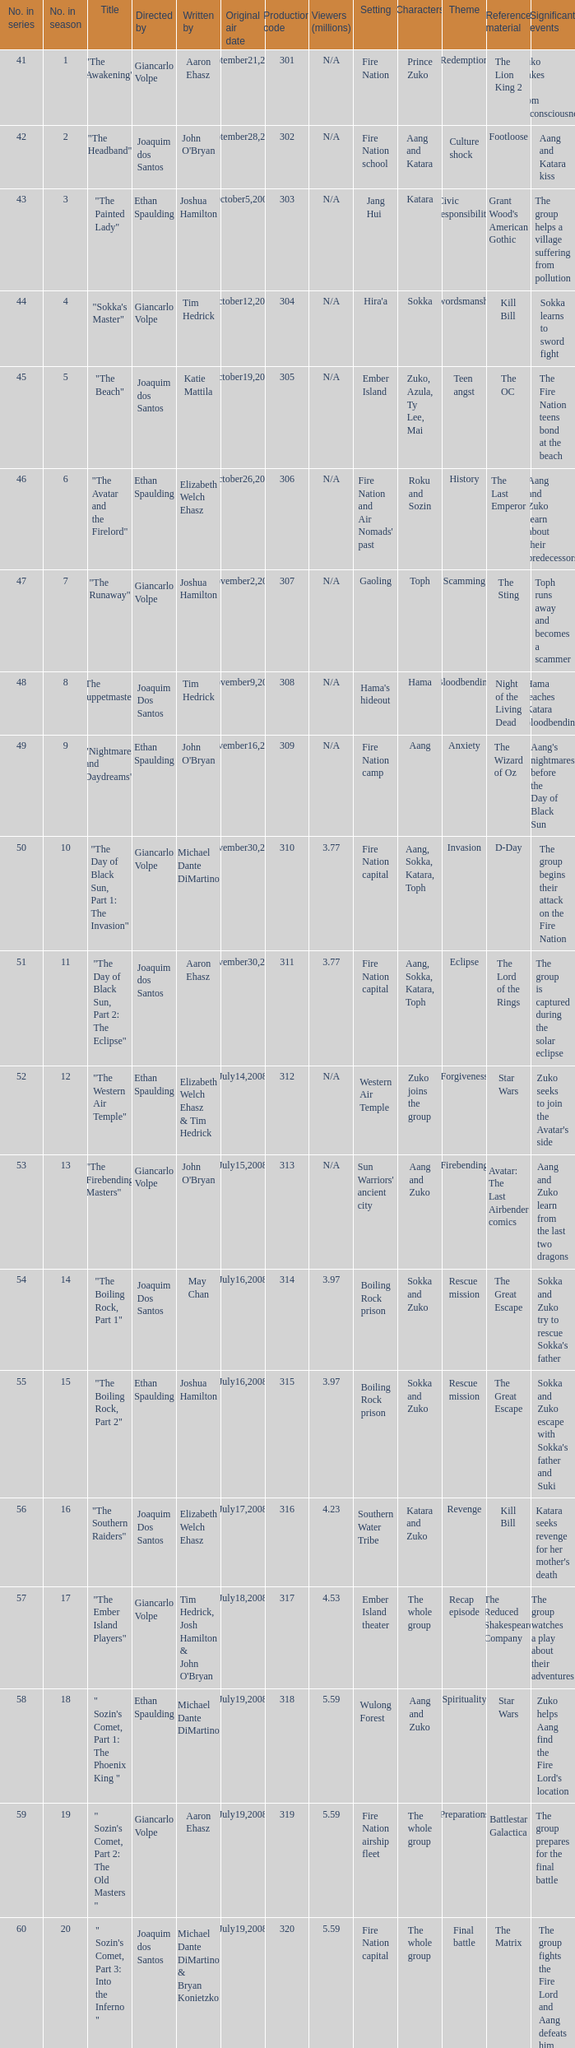Could you help me parse every detail presented in this table? {'header': ['No. in series', 'No. in season', 'Title', 'Directed by', 'Written by', 'Original air date', 'Production code', 'Viewers (millions)', 'Setting', 'Characters', 'Theme', 'Reference material', 'Significant events '], 'rows': [['41', '1', '"The Awakening"', 'Giancarlo Volpe', 'Aaron Ehasz', 'September21,2007', '301', 'N/A', 'Fire Nation', 'Prince Zuko', 'Redemption', 'The Lion King 2', 'Zuko wakes up from unconsciousness '], ['42', '2', '"The Headband"', 'Joaquim dos Santos', "John O'Bryan", 'September28,2007', '302', 'N/A', 'Fire Nation school', 'Aang and Katara', 'Culture shock', 'Footloose', 'Aang and Katara kiss '], ['43', '3', '"The Painted Lady"', 'Ethan Spaulding', 'Joshua Hamilton', 'October5,2007', '303', 'N/A', 'Jang Hui', 'Katara', 'Civic responsibility', "Grant Wood's American Gothic", 'The group helps a village suffering from pollution '], ['44', '4', '"Sokka\'s Master"', 'Giancarlo Volpe', 'Tim Hedrick', 'October12,2007', '304', 'N/A', "Hira'a", 'Sokka', 'Swordsmanship', 'Kill Bill', 'Sokka learns to sword fight '], ['45', '5', '"The Beach"', 'Joaquim dos Santos', 'Katie Mattila', 'October19,2007', '305', 'N/A', 'Ember Island', 'Zuko, Azula, Ty Lee, Mai', 'Teen angst', 'The OC', 'The Fire Nation teens bond at the beach '], ['46', '6', '"The Avatar and the Firelord"', 'Ethan Spaulding', 'Elizabeth Welch Ehasz', 'October26,2007', '306', 'N/A', "Fire Nation and Air Nomads' past", 'Roku and Sozin', 'History', 'The Last Emperor', 'Aang and Zuko learn about their predecessors '], ['47', '7', '"The Runaway"', 'Giancarlo Volpe', 'Joshua Hamilton', 'November2,2007', '307', 'N/A', 'Gaoling', 'Toph', 'Scamming', 'The Sting', 'Toph runs away and becomes a scammer '], ['48', '8', '"The Puppetmaster"', 'Joaquim Dos Santos', 'Tim Hedrick', 'November9,2007', '308', 'N/A', "Hama's hideout", 'Hama', 'Bloodbending', 'Night of the Living Dead', 'Hama teaches Katara bloodbending '], ['49', '9', '"Nightmares and Daydreams"', 'Ethan Spaulding', "John O'Bryan", 'November16,2007', '309', 'N/A', 'Fire Nation camp', 'Aang', 'Anxiety', 'The Wizard of Oz', "Aang's nightmares before the Day of Black Sun "], ['50', '10', '"The Day of Black Sun, Part 1: The Invasion"', 'Giancarlo Volpe', 'Michael Dante DiMartino', 'November30,2007', '310', '3.77', 'Fire Nation capital', 'Aang, Sokka, Katara, Toph', 'Invasion', 'D-Day', 'The group begins their attack on the Fire Nation '], ['51', '11', '"The Day of Black Sun, Part 2: The Eclipse"', 'Joaquim dos Santos', 'Aaron Ehasz', 'November30,2007', '311', '3.77', 'Fire Nation capital', 'Aang, Sokka, Katara, Toph', 'Eclipse', 'The Lord of the Rings', 'The group is captured during the solar eclipse '], ['52', '12', '"The Western Air Temple"', 'Ethan Spaulding', 'Elizabeth Welch Ehasz & Tim Hedrick', 'July14,2008', '312', 'N/A', 'Western Air Temple', 'Zuko joins the group', 'Forgiveness', 'Star Wars', "Zuko seeks to join the Avatar's side "], ['53', '13', '"The Firebending Masters"', 'Giancarlo Volpe', "John O'Bryan", 'July15,2008', '313', 'N/A', "Sun Warriors' ancient city", 'Aang and Zuko', 'Firebending', 'Avatar: The Last Airbender comics', 'Aang and Zuko learn from the last two dragons '], ['54', '14', '"The Boiling Rock, Part 1"', 'Joaquim Dos Santos', 'May Chan', 'July16,2008', '314', '3.97', 'Boiling Rock prison', 'Sokka and Zuko', 'Rescue mission', 'The Great Escape', "Sokka and Zuko try to rescue Sokka's father "], ['55', '15', '"The Boiling Rock, Part 2"', 'Ethan Spaulding', 'Joshua Hamilton', 'July16,2008', '315', '3.97', 'Boiling Rock prison', 'Sokka and Zuko', 'Rescue mission', 'The Great Escape', "Sokka and Zuko escape with Sokka's father and Suki "], ['56', '16', '"The Southern Raiders"', 'Joaquim Dos Santos', 'Elizabeth Welch Ehasz', 'July17,2008', '316', '4.23', 'Southern Water Tribe', 'Katara and Zuko', 'Revenge', 'Kill Bill', "Katara seeks revenge for her mother's death "], ['57', '17', '"The Ember Island Players"', 'Giancarlo Volpe', "Tim Hedrick, Josh Hamilton & John O'Bryan", 'July18,2008', '317', '4.53', 'Ember Island theater', 'The whole group', 'Recap episode', 'The Reduced Shakespeare Company', 'The group watches a play about their adventures '], ['58', '18', '" Sozin\'s Comet, Part 1: The Phoenix King "', 'Ethan Spaulding', 'Michael Dante DiMartino', 'July19,2008', '318', '5.59', 'Wulong Forest', 'Aang and Zuko', 'Spirituality', 'Star Wars', "Zuko helps Aang find the Fire Lord's location "], ['59', '19', '" Sozin\'s Comet, Part 2: The Old Masters "', 'Giancarlo Volpe', 'Aaron Ehasz', 'July19,2008', '319', '5.59', 'Fire Nation airship fleet', 'The whole group', 'Preparations', 'Battlestar Galactica', 'The group prepares for the final battle '], ['60', '20', '" Sozin\'s Comet, Part 3: Into the Inferno "', 'Joaquim dos Santos', 'Michael Dante DiMartino & Bryan Konietzko', 'July19,2008', '320', '5.59', 'Fire Nation capital', 'The whole group', 'Final battle', 'The Matrix', 'The group fights the Fire Lord and Aang defeats him with Avatar State']]} What season has an episode written by john o'bryan and directed by ethan spaulding? 9.0. 